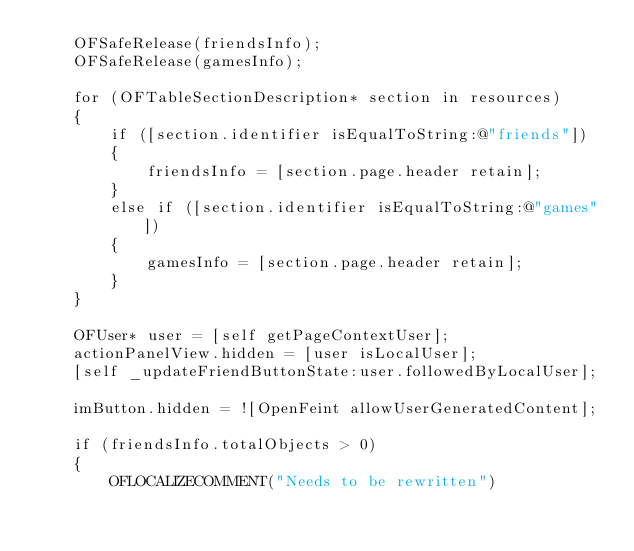Convert code to text. <code><loc_0><loc_0><loc_500><loc_500><_ObjectiveC_>	OFSafeRelease(friendsInfo);
	OFSafeRelease(gamesInfo);
	
	for (OFTableSectionDescription* section in resources)
	{
		if ([section.identifier isEqualToString:@"friends"])
		{
			friendsInfo = [section.page.header retain];
		}
		else if ([section.identifier isEqualToString:@"games"])
		{
			gamesInfo = [section.page.header retain];
		}
	}
	
	OFUser* user = [self getPageContextUser];
	actionPanelView.hidden = [user isLocalUser];
	[self _updateFriendButtonState:user.followedByLocalUser];
	
	imButton.hidden = ![OpenFeint allowUserGeneratedContent];
	
	if (friendsInfo.totalObjects > 0)
	{
        OFLOCALIZECOMMENT("Needs to be rewritten")</code> 